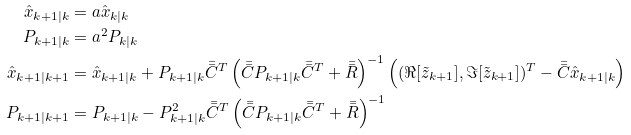Convert formula to latex. <formula><loc_0><loc_0><loc_500><loc_500>\hat { x } _ { k + 1 | k } & = a \hat { x } _ { k | k } \\ P _ { k + 1 | k } & = a ^ { 2 } P _ { k | k } \\ \hat { x } _ { k + 1 | k + 1 } & = \hat { x } _ { k + 1 | k } + P _ { k + 1 | k } \bar { \bar { C } } ^ { T } \left ( \bar { \bar { C } } P _ { k + 1 | k } \bar { \bar { C } } ^ { T } + \bar { \bar { R } } \right ) ^ { - 1 } \left ( ( \Re [ \tilde { z } _ { k + 1 } ] , \Im [ \tilde { z } _ { k + 1 } ] ) ^ { T } - \bar { \bar { C } } \hat { x } _ { k + 1 | k } \right ) \\ P _ { k + 1 | k + 1 } & = P _ { k + 1 | k } - P _ { k + 1 | k } ^ { 2 } \bar { \bar { C } } ^ { T } \left ( \bar { \bar { C } } P _ { k + 1 | k } \bar { \bar { C } } ^ { T } + \bar { \bar { R } } \right ) ^ { - 1 }</formula> 